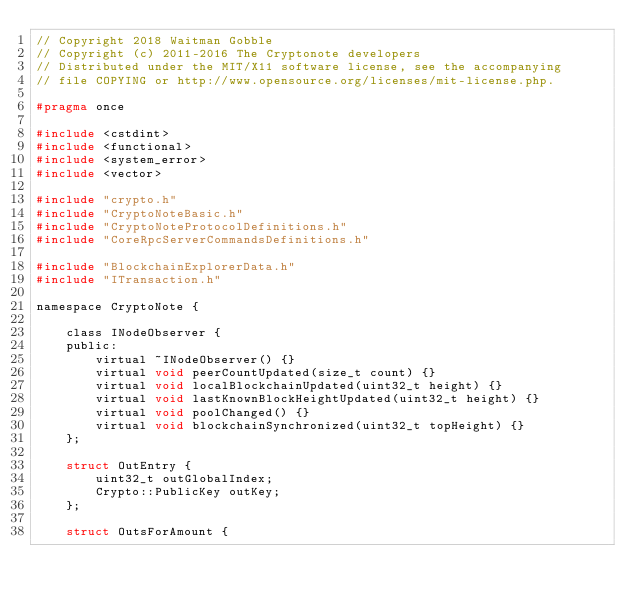<code> <loc_0><loc_0><loc_500><loc_500><_C_>// Copyright 2018 Waitman Gobble
// Copyright (c) 2011-2016 The Cryptonote developers
// Distributed under the MIT/X11 software license, see the accompanying
// file COPYING or http://www.opensource.org/licenses/mit-license.php.

#pragma once

#include <cstdint>
#include <functional>
#include <system_error>
#include <vector>

#include "crypto.h"
#include "CryptoNoteBasic.h"
#include "CryptoNoteProtocolDefinitions.h"
#include "CoreRpcServerCommandsDefinitions.h"

#include "BlockchainExplorerData.h"
#include "ITransaction.h"

namespace CryptoNote {

	class INodeObserver {
	public:
		virtual ~INodeObserver() {}
		virtual void peerCountUpdated(size_t count) {}
		virtual void localBlockchainUpdated(uint32_t height) {}
		virtual void lastKnownBlockHeightUpdated(uint32_t height) {}
		virtual void poolChanged() {}
		virtual void blockchainSynchronized(uint32_t topHeight) {}
	};

	struct OutEntry {
		uint32_t outGlobalIndex;
		Crypto::PublicKey outKey;
	};

	struct OutsForAmount {</code> 